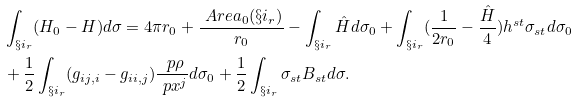<formula> <loc_0><loc_0><loc_500><loc_500>& \int _ { \S i _ { r } } ( H _ { 0 } - H ) d \sigma = 4 \pi r _ { 0 } + \frac { \ A r e a _ { 0 } ( \S i _ { r } ) } { r _ { 0 } } - \int _ { \S i _ { r } } \hat { H } d \sigma _ { 0 } + \int _ { \S i _ { r } } ( \frac { 1 } { 2 r _ { 0 } } - \frac { \hat { H } } { 4 } ) h ^ { s t } \sigma _ { s t } d \sigma _ { 0 } \\ & + \frac { 1 } { 2 } \int _ { \S i _ { r } } ( g _ { i j , i } - g _ { i i , j } ) \frac { \ p \rho } { \ p x ^ { j } } d \sigma _ { 0 } + \frac { 1 } { 2 } \int _ { \S i _ { r } } \sigma _ { s t } B _ { s t } d \sigma .</formula> 